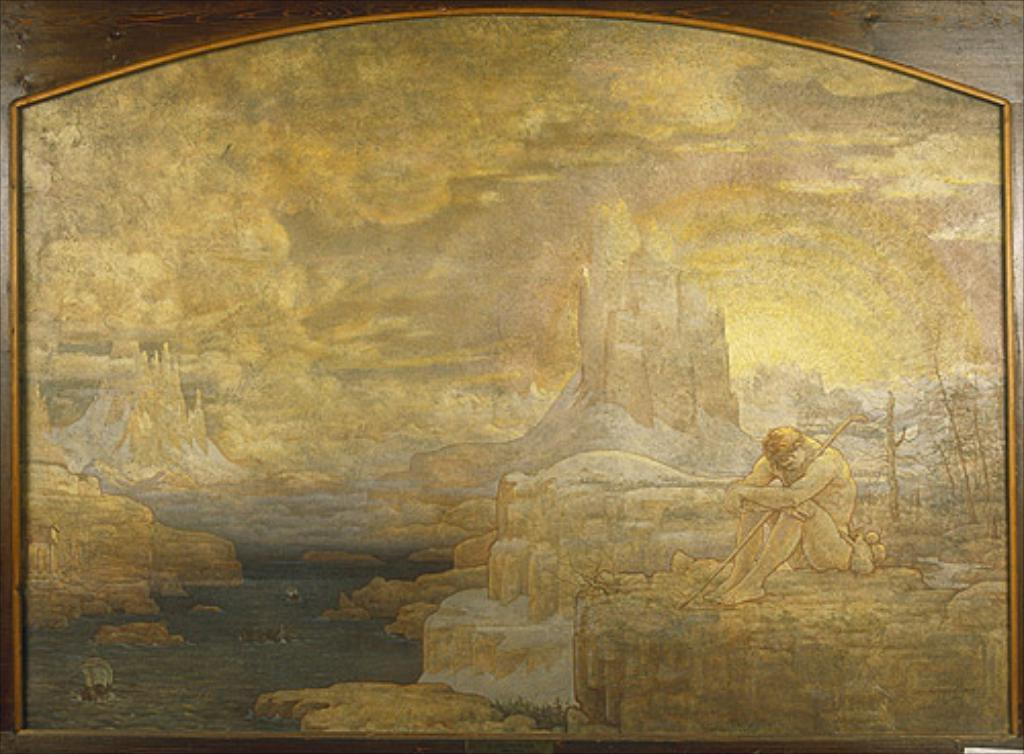What is on the wooden board in the image? There is a frame on the wooden board in the image. What is inside the frame? The frame contains a painting. What is the subject of the painting? The painting depicts a person sitting on a rock. What can be seen in the background of the painting? Water, buildings, and clouds are visible in the painting. What type of punishment is being administered to the person in the painting? There is no indication of punishment in the painting; it depicts a person sitting on a rock. Is the rifle mentioned in the image? No, there is no rifle present in the image. 